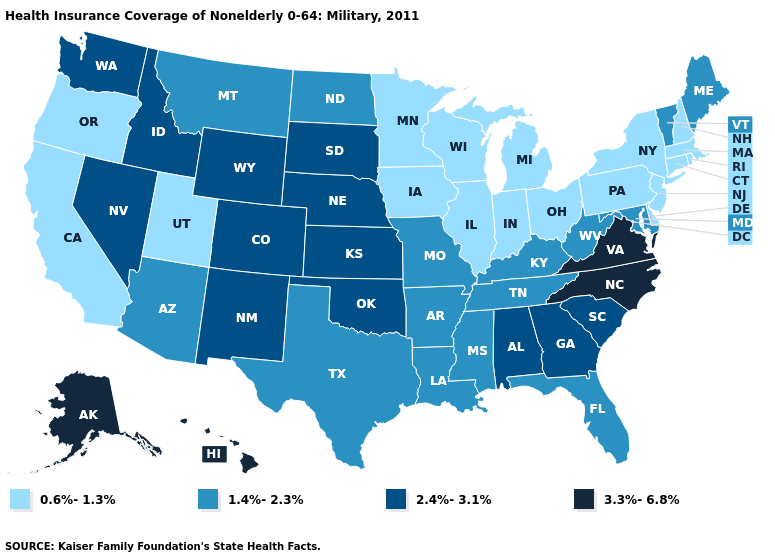Among the states that border Idaho , which have the lowest value?
Keep it brief. Oregon, Utah. What is the value of Missouri?
Give a very brief answer. 1.4%-2.3%. What is the lowest value in the USA?
Write a very short answer. 0.6%-1.3%. Does Oregon have the same value as Missouri?
Quick response, please. No. Name the states that have a value in the range 1.4%-2.3%?
Be succinct. Arizona, Arkansas, Florida, Kentucky, Louisiana, Maine, Maryland, Mississippi, Missouri, Montana, North Dakota, Tennessee, Texas, Vermont, West Virginia. Which states have the highest value in the USA?
Short answer required. Alaska, Hawaii, North Carolina, Virginia. What is the value of Ohio?
Answer briefly. 0.6%-1.3%. Does Maine have a higher value than Michigan?
Give a very brief answer. Yes. What is the value of Vermont?
Be succinct. 1.4%-2.3%. Does South Dakota have the lowest value in the USA?
Write a very short answer. No. Name the states that have a value in the range 1.4%-2.3%?
Quick response, please. Arizona, Arkansas, Florida, Kentucky, Louisiana, Maine, Maryland, Mississippi, Missouri, Montana, North Dakota, Tennessee, Texas, Vermont, West Virginia. Name the states that have a value in the range 1.4%-2.3%?
Short answer required. Arizona, Arkansas, Florida, Kentucky, Louisiana, Maine, Maryland, Mississippi, Missouri, Montana, North Dakota, Tennessee, Texas, Vermont, West Virginia. What is the highest value in the South ?
Be succinct. 3.3%-6.8%. What is the lowest value in states that border New Mexico?
Concise answer only. 0.6%-1.3%. Does Indiana have the highest value in the MidWest?
Write a very short answer. No. 